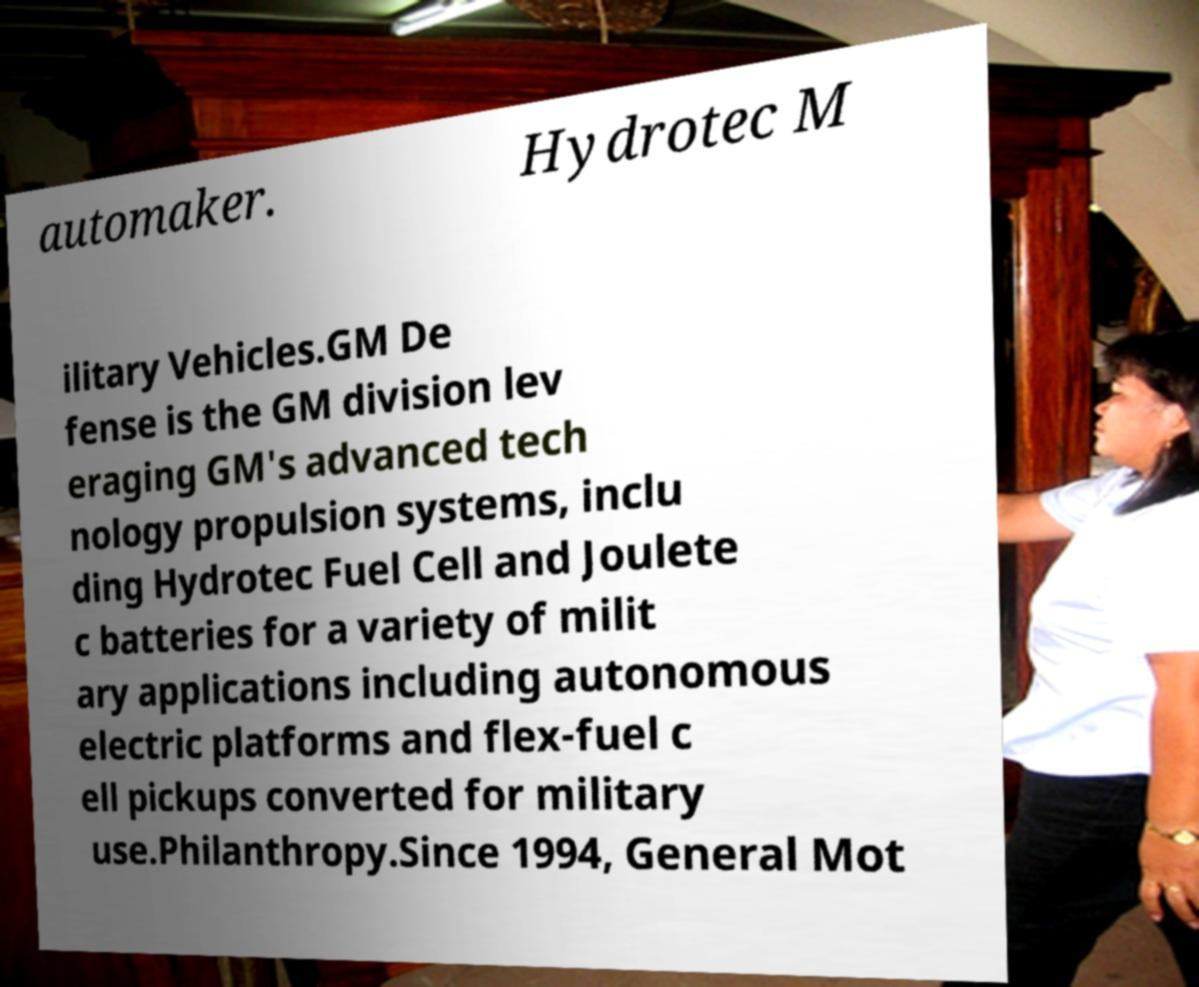Please read and relay the text visible in this image. What does it say? automaker. Hydrotec M ilitary Vehicles.GM De fense is the GM division lev eraging GM's advanced tech nology propulsion systems, inclu ding Hydrotec Fuel Cell and Joulete c batteries for a variety of milit ary applications including autonomous electric platforms and flex-fuel c ell pickups converted for military use.Philanthropy.Since 1994, General Mot 